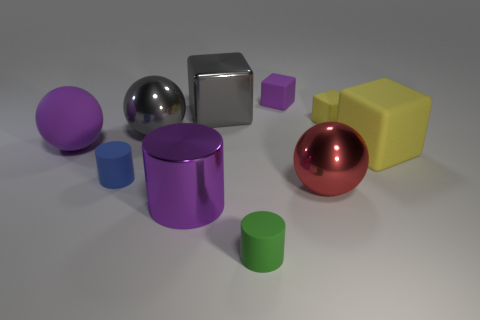Subtract all rubber balls. How many balls are left? 2 Subtract all green cylinders. How many cylinders are left? 2 Subtract all cylinders. How many objects are left? 7 Subtract 3 cubes. How many cubes are left? 1 Subtract all gray cylinders. Subtract all blue balls. How many cylinders are left? 3 Subtract all blue cubes. How many blue cylinders are left? 1 Subtract all blue objects. Subtract all green matte cylinders. How many objects are left? 8 Add 2 purple spheres. How many purple spheres are left? 3 Add 1 large yellow rubber things. How many large yellow rubber things exist? 2 Subtract 0 cyan spheres. How many objects are left? 10 